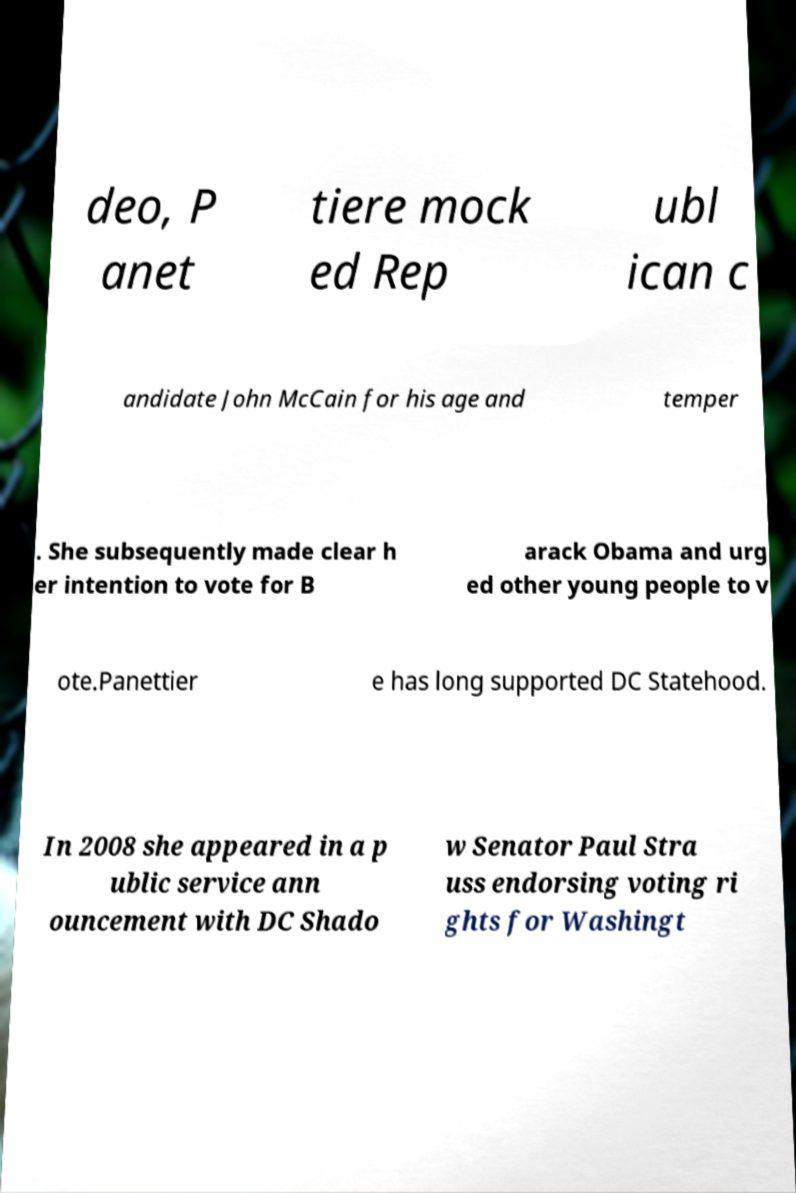There's text embedded in this image that I need extracted. Can you transcribe it verbatim? deo, P anet tiere mock ed Rep ubl ican c andidate John McCain for his age and temper . She subsequently made clear h er intention to vote for B arack Obama and urg ed other young people to v ote.Panettier e has long supported DC Statehood. In 2008 she appeared in a p ublic service ann ouncement with DC Shado w Senator Paul Stra uss endorsing voting ri ghts for Washingt 